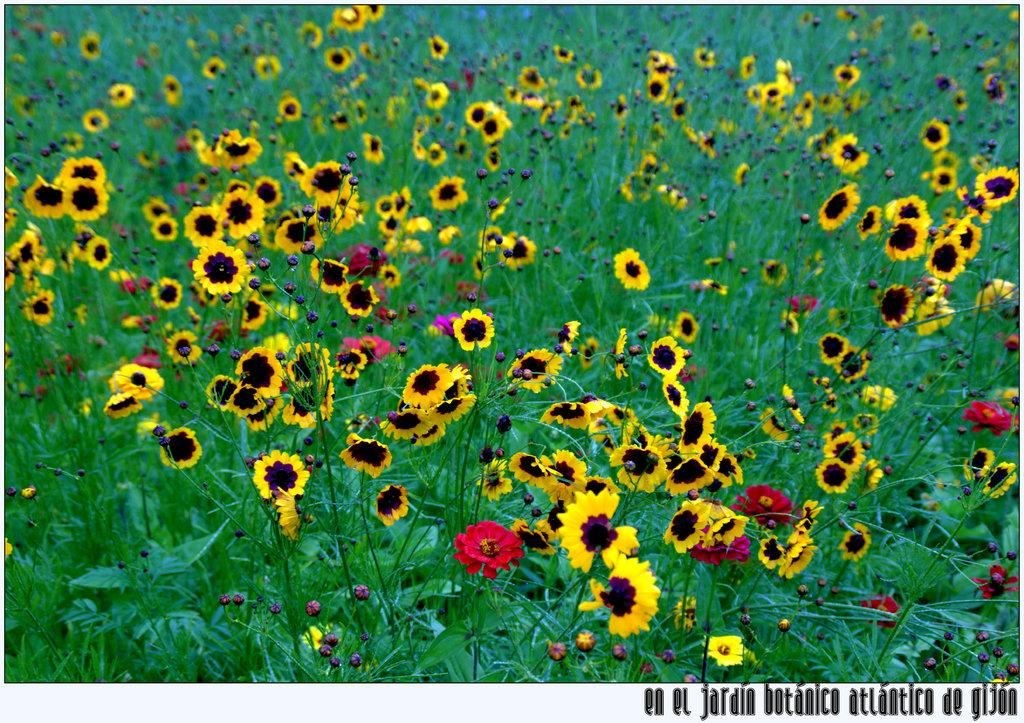What celestial bodies are depicted in the image? There are planets in the image. What type of flora can be seen in the image? There are yellow color flowers in the image. What type of straw is being used by the queen in the image? There is no queen or straw present in the image; it features planets and yellow flowers. 